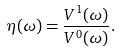<formula> <loc_0><loc_0><loc_500><loc_500>\eta ( \omega ) = \frac { V ^ { 1 } ( \omega ) } { V ^ { 0 } ( \omega ) } .</formula> 